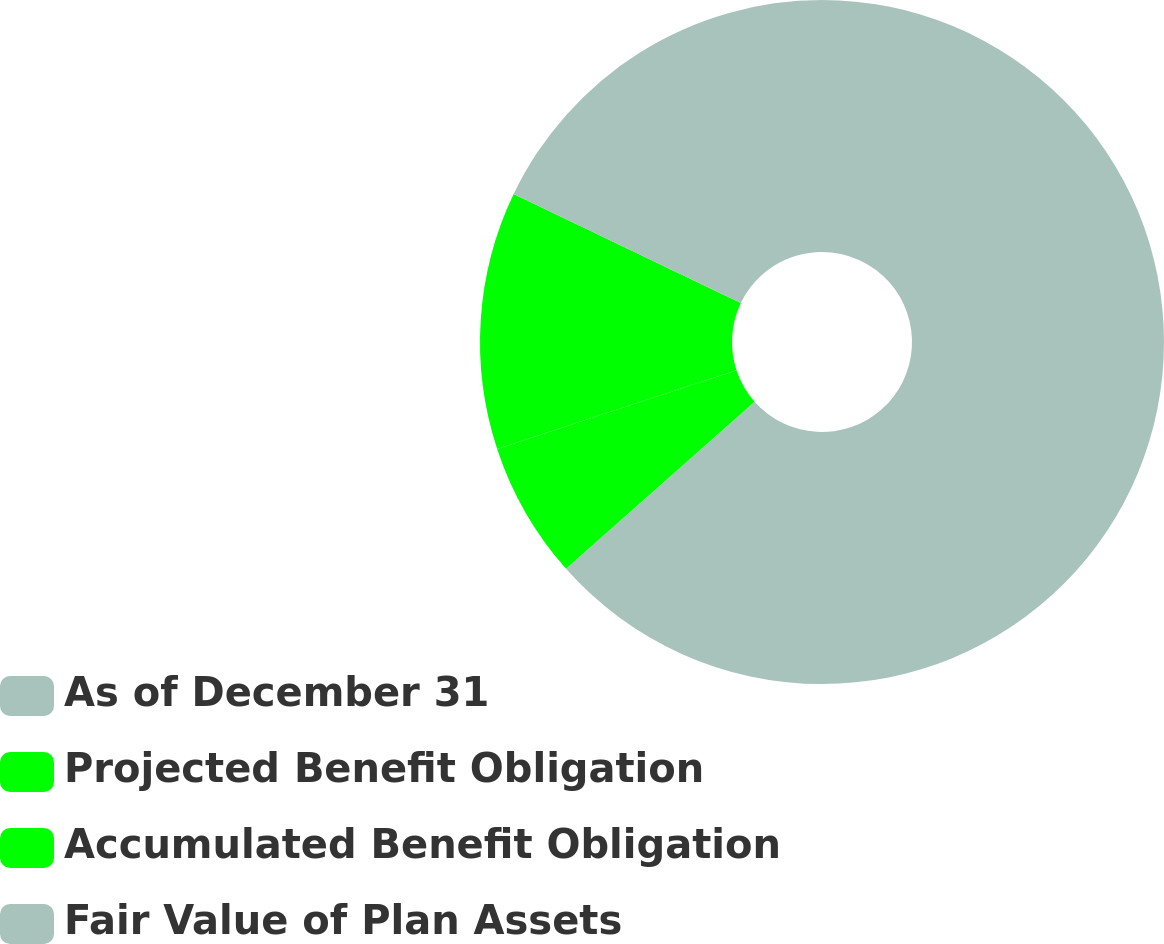Convert chart. <chart><loc_0><loc_0><loc_500><loc_500><pie_chart><fcel>As of December 31<fcel>Projected Benefit Obligation<fcel>Accumulated Benefit Obligation<fcel>Fair Value of Plan Assets<nl><fcel>63.46%<fcel>6.48%<fcel>12.18%<fcel>17.88%<nl></chart> 